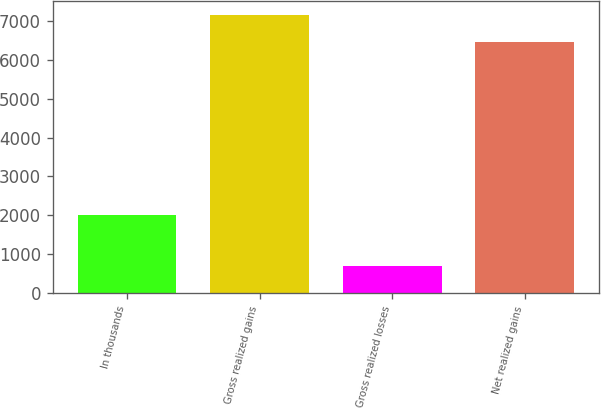Convert chart. <chart><loc_0><loc_0><loc_500><loc_500><bar_chart><fcel>In thousands<fcel>Gross realized gains<fcel>Gross realized losses<fcel>Net realized gains<nl><fcel>2008<fcel>7161<fcel>711<fcel>6450<nl></chart> 